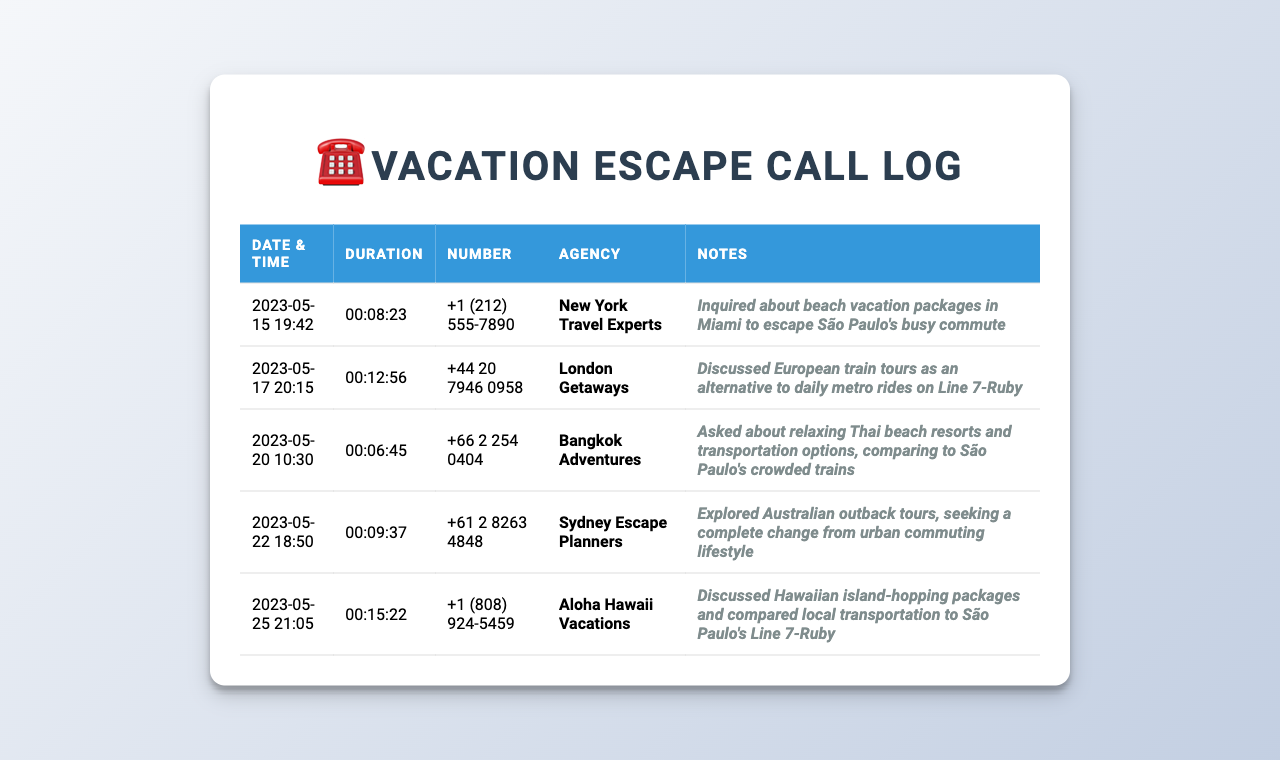what is the date of the first call? The first call was made on 2023-05-15.
Answer: 2023-05-15 how long was the longest call? The longest call can be identified by comparing the durations listed, which shows the call on 2023-05-25 lasted the longest at 00:15:22.
Answer: 00:15:22 who was contacted for the beach vacation packages? The call made on 2023-05-15 was for inquiries about beach vacation packages, specifically to New York Travel Experts.
Answer: New York Travel Experts how many calls were made to agencies in May 2023? There are a total of five calls listed, all made in May 2023.
Answer: 5 what type of vacation was discussed on the call with Bangkok Adventures? The call on 2023-05-20 involved inquiries about relaxing Thai beach resorts.
Answer: relaxing Thai beach resorts which agency was contacted about European train tours? The agency discussed for European train tours is London Getaways, contacted on 2023-05-17.
Answer: London Getaways what is the phone number for Aloha Hawaii Vacations? The phone number provided for Aloha Hawaii Vacations, contacted on 2023-05-25, is +1 (808) 924-5459.
Answer: +1 (808) 924-5459 what was the purpose of the call on 2023-05-22? The call on 2023-05-22 explored Australian outback tours as a complete change from urban commuting lifestyle.
Answer: explored Australian outback tours 